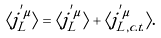<formula> <loc_0><loc_0><loc_500><loc_500>\langle j ^ { ^ { \prime } \mu } _ { L } \rangle = \langle j ^ { ^ { \prime } \mu } _ { L } \rangle + \langle j ^ { ^ { \prime } \mu } _ { L , c . t . } \rangle .</formula> 